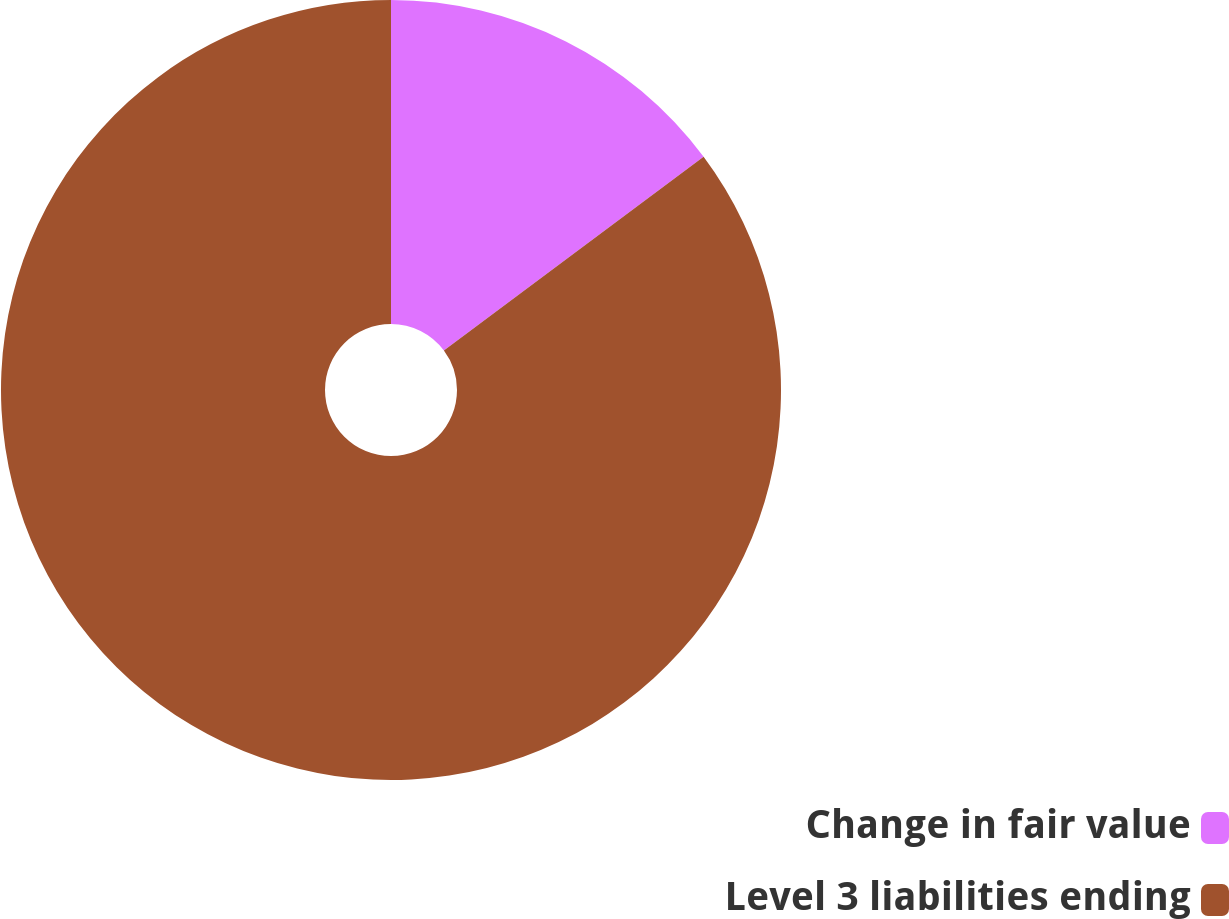<chart> <loc_0><loc_0><loc_500><loc_500><pie_chart><fcel>Change in fair value<fcel>Level 3 liabilities ending<nl><fcel>14.8%<fcel>85.2%<nl></chart> 